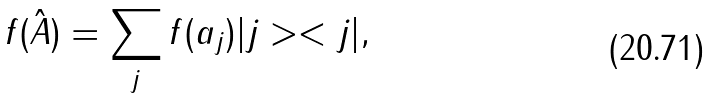Convert formula to latex. <formula><loc_0><loc_0><loc_500><loc_500>f ( \hat { A } ) = \sum _ { j } f ( a _ { j } ) | j > < j | ,</formula> 